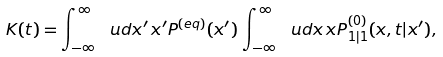<formula> <loc_0><loc_0><loc_500><loc_500>K ( t ) = \int _ { - \infty } ^ { \infty } \ u d x ^ { \prime } \, x ^ { \prime } P ^ { ( e q ) } ( x ^ { \prime } ) \, \int _ { - \infty } ^ { \infty } \ u d x \, x P ^ { ( 0 ) } _ { 1 | 1 } ( x , t | x ^ { \prime } ) ,</formula> 